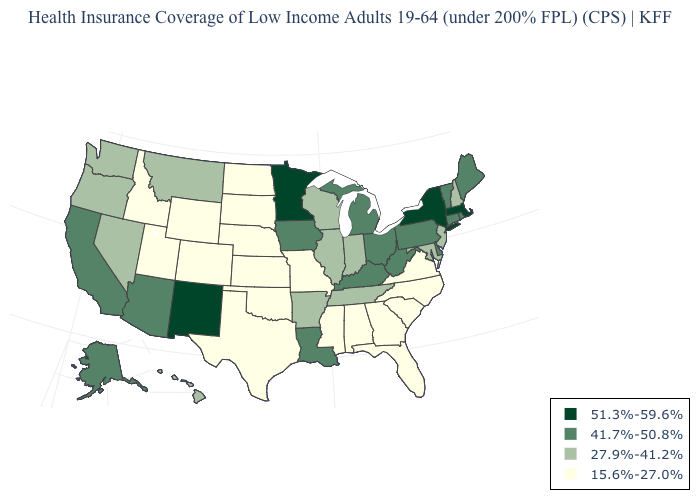What is the value of Hawaii?
Be succinct. 27.9%-41.2%. Among the states that border Nevada , does Arizona have the highest value?
Give a very brief answer. Yes. What is the value of South Carolina?
Give a very brief answer. 15.6%-27.0%. Does the map have missing data?
Concise answer only. No. Name the states that have a value in the range 51.3%-59.6%?
Be succinct. Massachusetts, Minnesota, New Mexico, New York. What is the lowest value in the USA?
Keep it brief. 15.6%-27.0%. Does Iowa have the lowest value in the USA?
Write a very short answer. No. Name the states that have a value in the range 51.3%-59.6%?
Concise answer only. Massachusetts, Minnesota, New Mexico, New York. Name the states that have a value in the range 27.9%-41.2%?
Be succinct. Arkansas, Hawaii, Illinois, Indiana, Maryland, Montana, Nevada, New Hampshire, New Jersey, Oregon, Tennessee, Washington, Wisconsin. How many symbols are there in the legend?
Keep it brief. 4. What is the value of Colorado?
Give a very brief answer. 15.6%-27.0%. Among the states that border New York , does Connecticut have the lowest value?
Keep it brief. No. Is the legend a continuous bar?
Be succinct. No. Does the map have missing data?
Quick response, please. No. Is the legend a continuous bar?
Write a very short answer. No. 